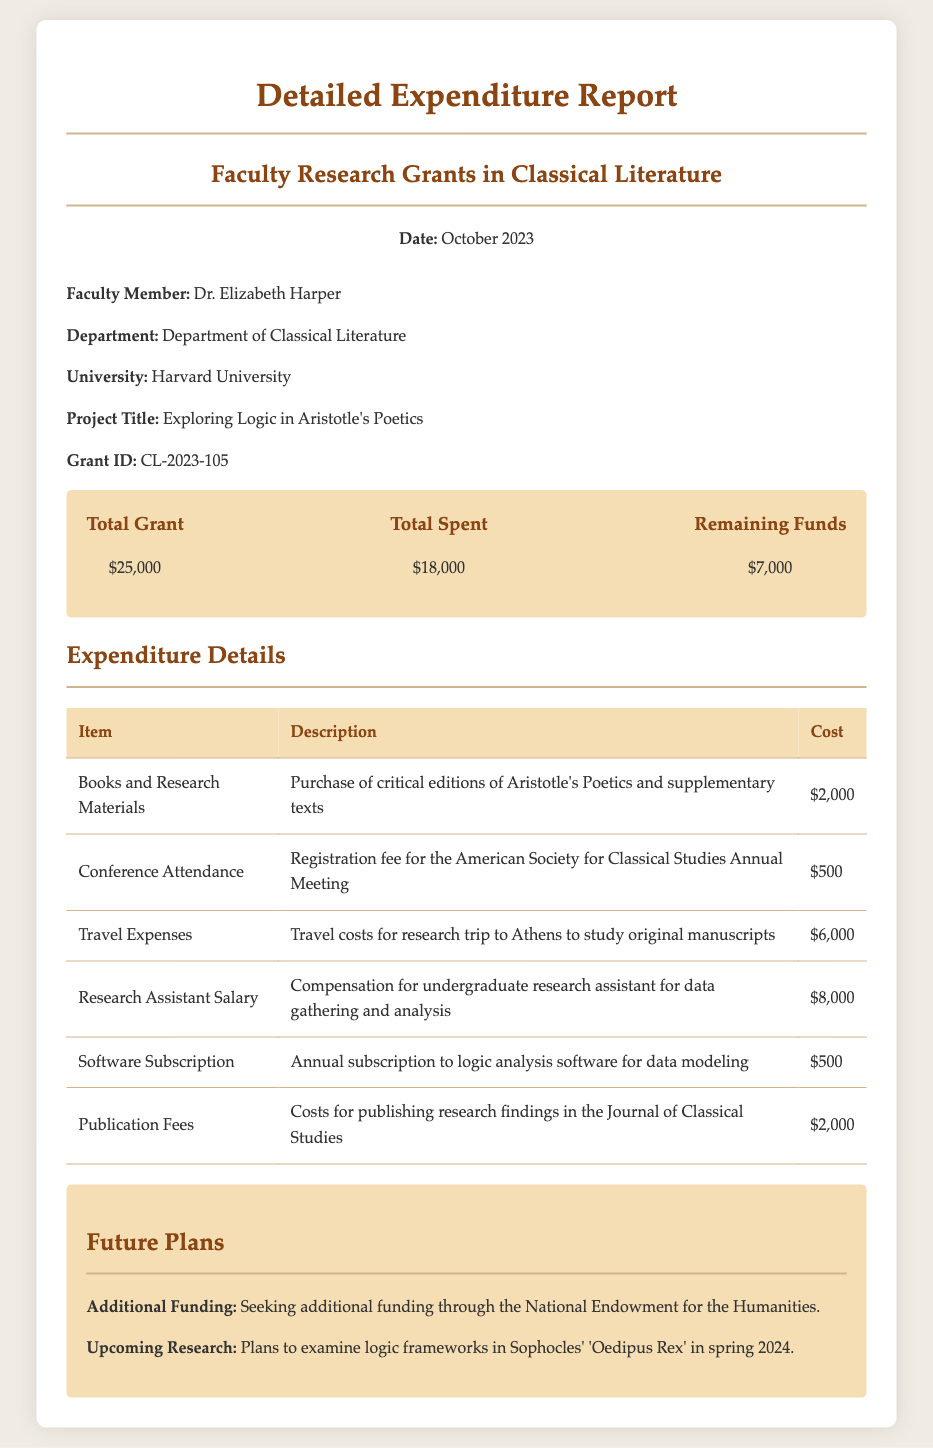what is the total grant amount? The total grant amount is explicitly stated in the budget overview as $25,000.
Answer: $25,000 who is the faculty member associated with the project? The faculty member's name is provided in the document as Dr. Elizabeth Harper.
Answer: Dr. Elizabeth Harper what was the cost of travel expenses? The cost for travel expenses is given in the expenditure details as $6,000.
Answer: $6,000 what project title is associated with the grant? The project title is listed in the document as "Exploring Logic in Aristotle's Poetics."
Answer: Exploring Logic in Aristotle's Poetics how much funds remain after expenditure? The remaining funds after expenditure are noted in the budget overview as $7,000.
Answer: $7,000 what is the total amount spent? The total amount spent is provided in the budget overview as $18,000.
Answer: $18,000 which department does Dr. Elizabeth Harper belong to? The department is stated in the document as the Department of Classical Literature.
Answer: Department of Classical Literature what are the future research plans mentioned? The future research plans state an examination of logic frameworks in Sophocles' 'Oedipus Rex.'
Answer: Examine logic frameworks in Sophocles' 'Oedipus Rex' what is the cost of the research assistant's salary? The salary for the research assistant is detailed in the expenditure section as $8,000.
Answer: $8,000 